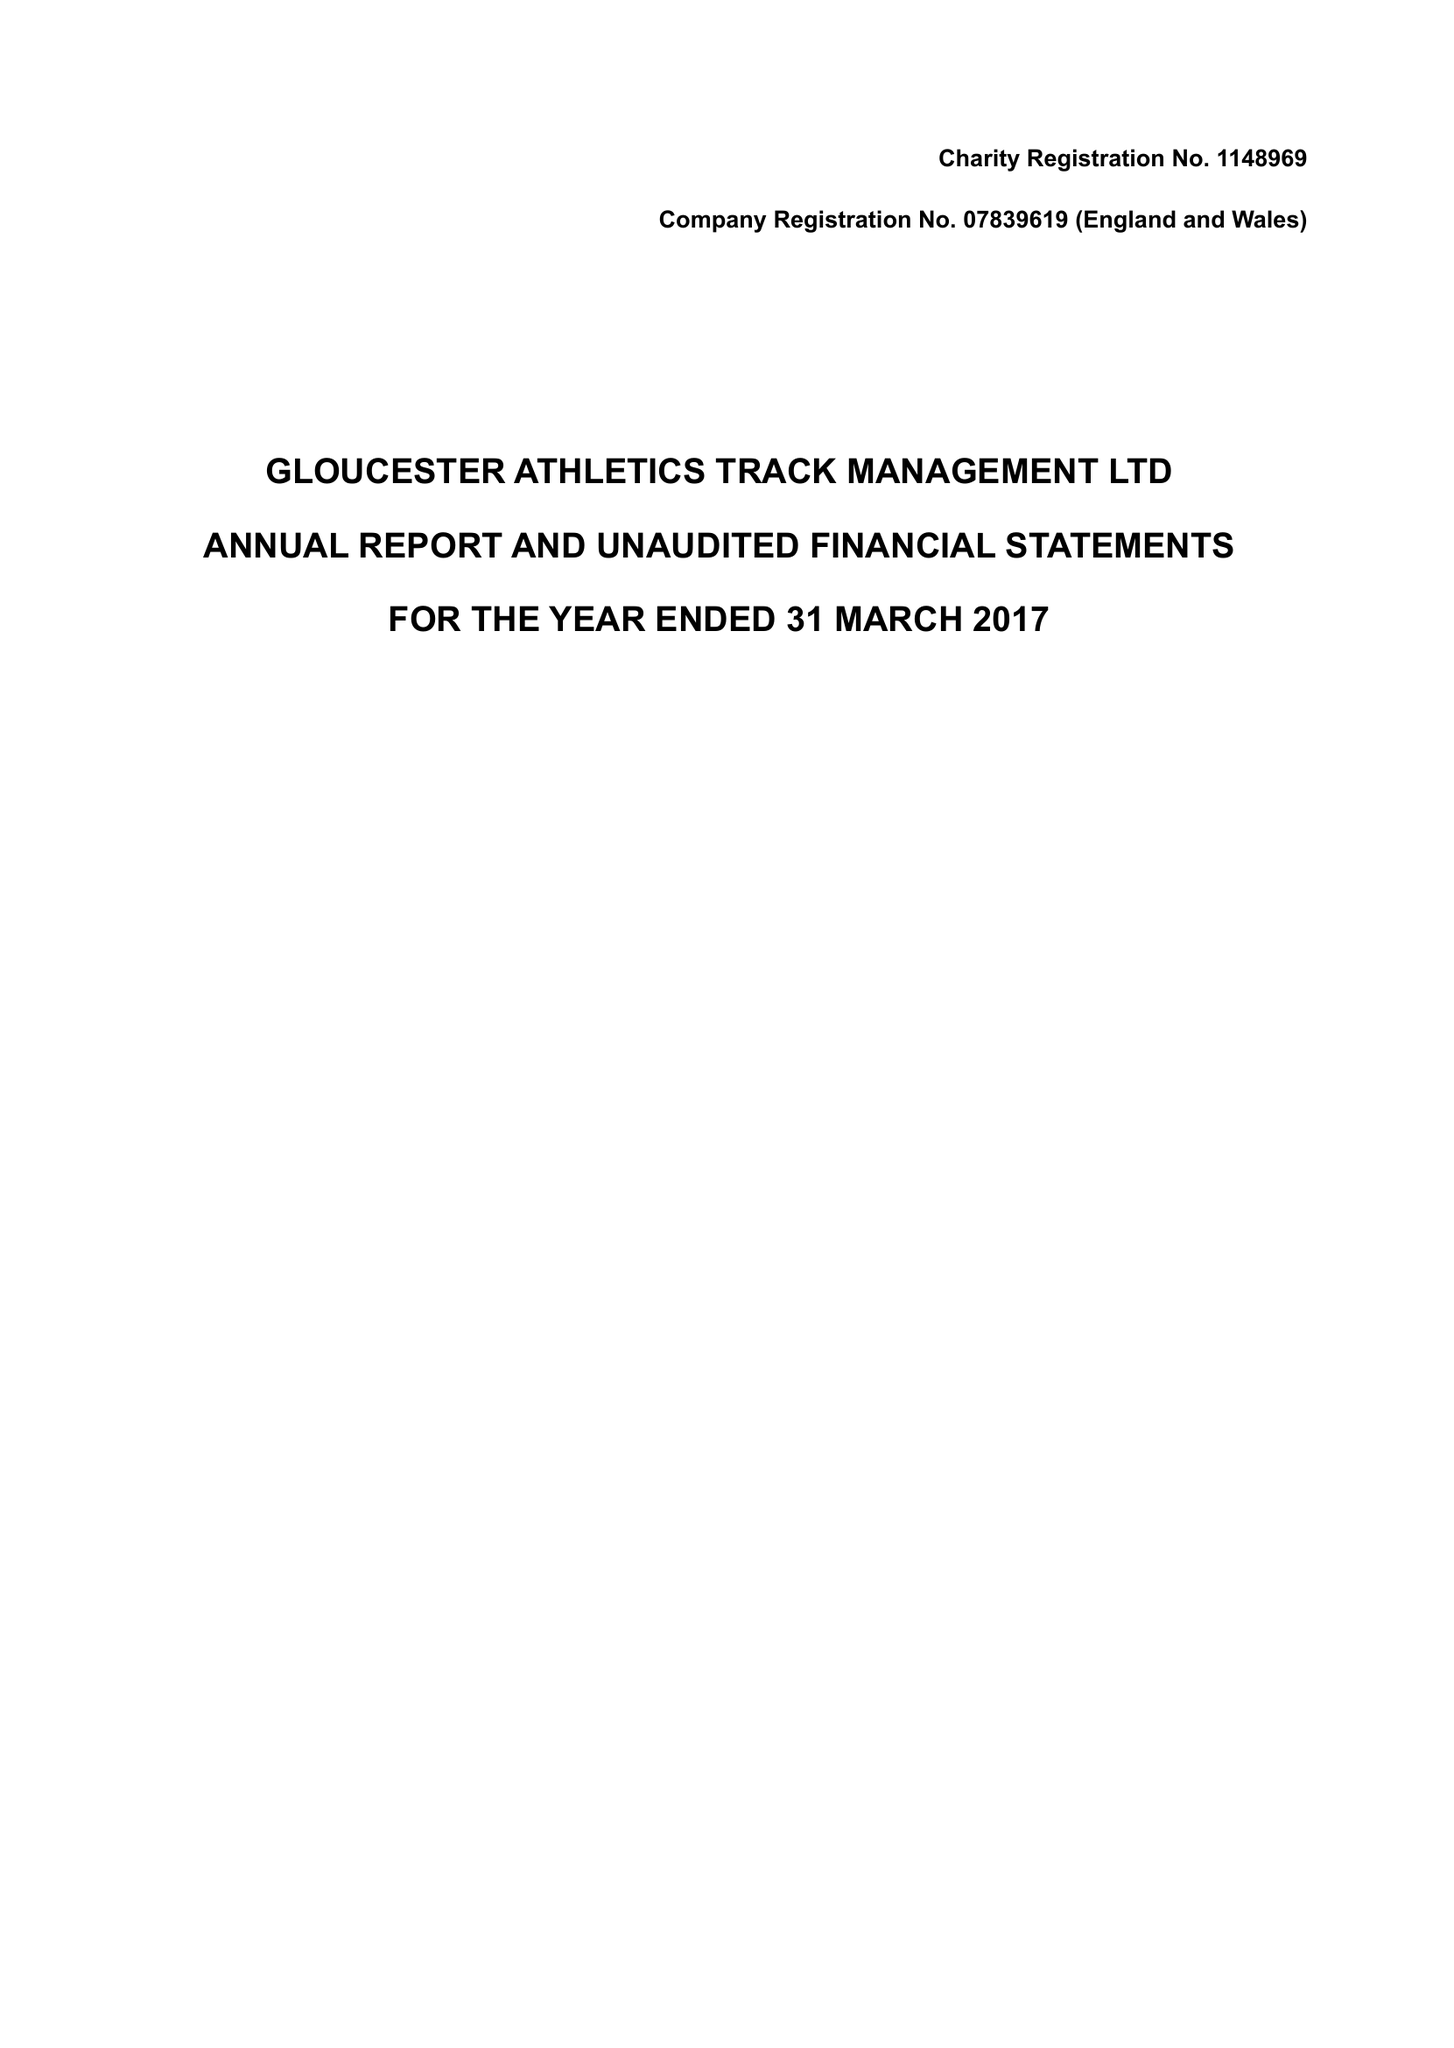What is the value for the address__post_town?
Answer the question using a single word or phrase. GLOUCESTER 